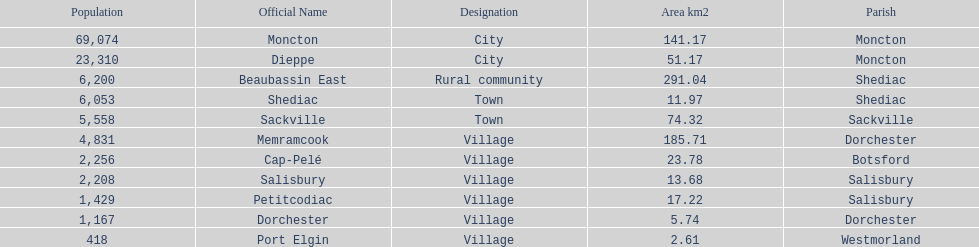The only rural community on the list Beaubassin East. 